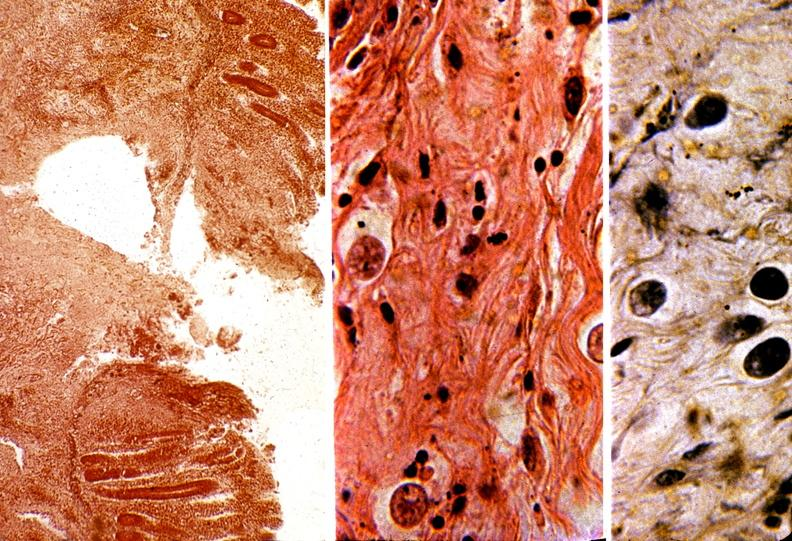does close-up of lesion show colon, amebic colitis?
Answer the question using a single word or phrase. No 